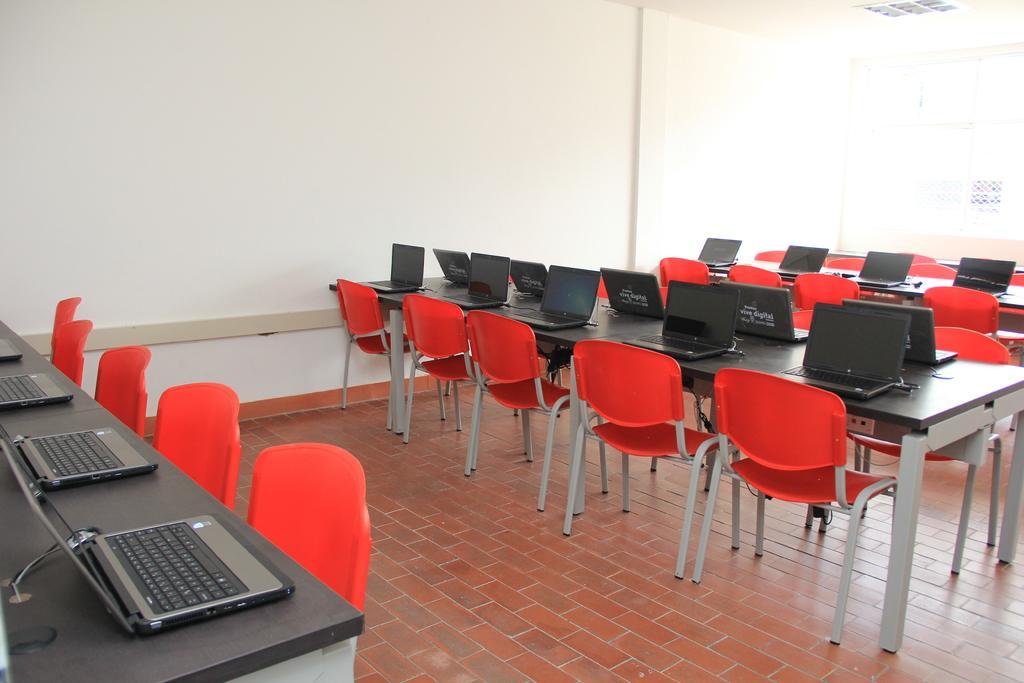Describe this image in one or two sentences. This picture is clicked inside a room. On the left bottom of the picture, we see a table on which four laptops are placed and beside that, we see five red chairs. On the right, on the middle of this picture, we see a table on which many laptops are placed. We even see many chairs. Behind that, we see a wall which is white in color and on the right top of the picture, we see a window. 